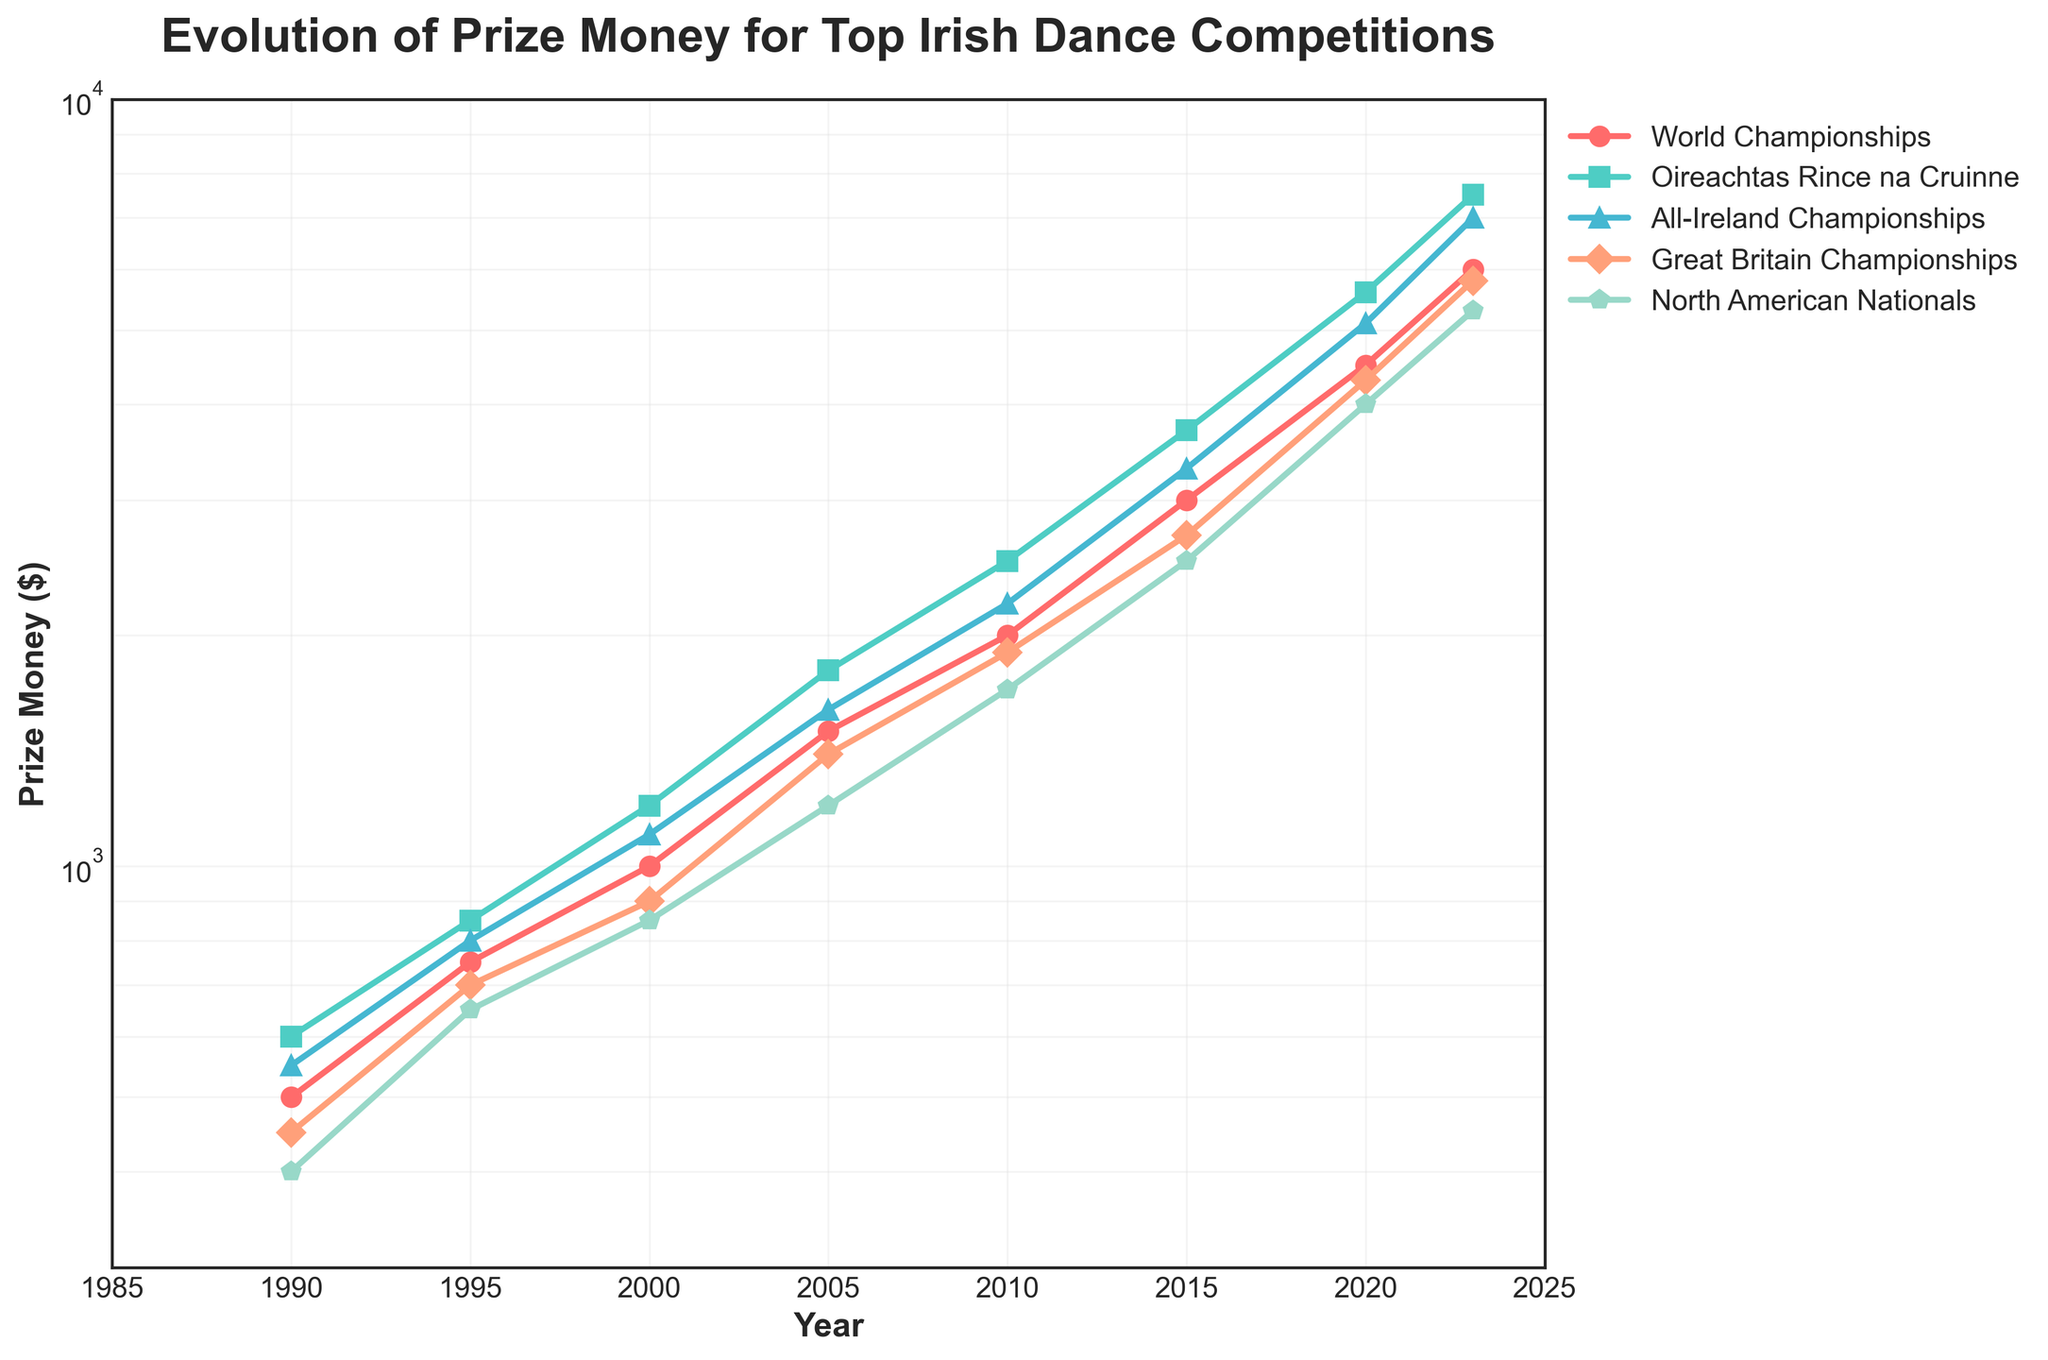What is the title of the figure? The title of the figure is displayed at the top of the plot and provides a summary of what the plot is about.
Answer: Evolution of Prize Money for Top Irish Dance Competitions What is the y-axis scale used in the plot? The y-axis scale is used to represent the range of prize money amounts. In this figure, it uses a logarithmic scale.
Answer: Logarithmic Which competition had the highest prize money in 2023? In the plot, look for the line that is at the highest point on the y-axis for the year 2023 (latest year on the x-axis).
Answer: Oireachtas Rince na Cruinne What is the color of the line representing the All-Ireland Championships? Identify the line corresponding to the All-Ireland Championships from the legend and note its color.
Answer: Blue Which competition shows the most significant increase in prize money from 1990 to 2023? Compare the starting and ending points of each line from 1990 to 2023 to see which line has the steepest incline.
Answer: Oireachtas Rince na Cruinne In what year did the prize money for the World Championships first exceed $2000? Locate the World Championships line and trace it along the x-axis to find the year where it first reaches above the $2000 mark on the y-axis.
Answer: 2010 Between which two consecutive years did the North American Nationals see the biggest increase in prize money? Track the line representing the North American Nationals and note the largest vertical jump between two consecutive data points.
Answer: 2015 to 2020 How many competitions are tracked in the plot? Use the legend or count the number of distinct lines in the plot to determine how many competitions are being tracked.
Answer: 5 Which competition had the lowest prize money in 1990? Look at the starting points of all lines for the year 1990 and identify the lowest one.
Answer: North American Nationals What is the average prize money for the Great Britain Championships between 2000 and 2010? Sum the prize money amounts for the Great Britain Championships for the years 2000, 2005, and 2010, then divide by the number of data points (3).
Answer: $1233.33 Is the prize money for the All-Ireland Championships always higher than that for the Great Britain Championships? Compare the y-values for All-Ireland Championships and Great Britain Championships at each year to see if All-Ireland is always higher.
Answer: Yes 